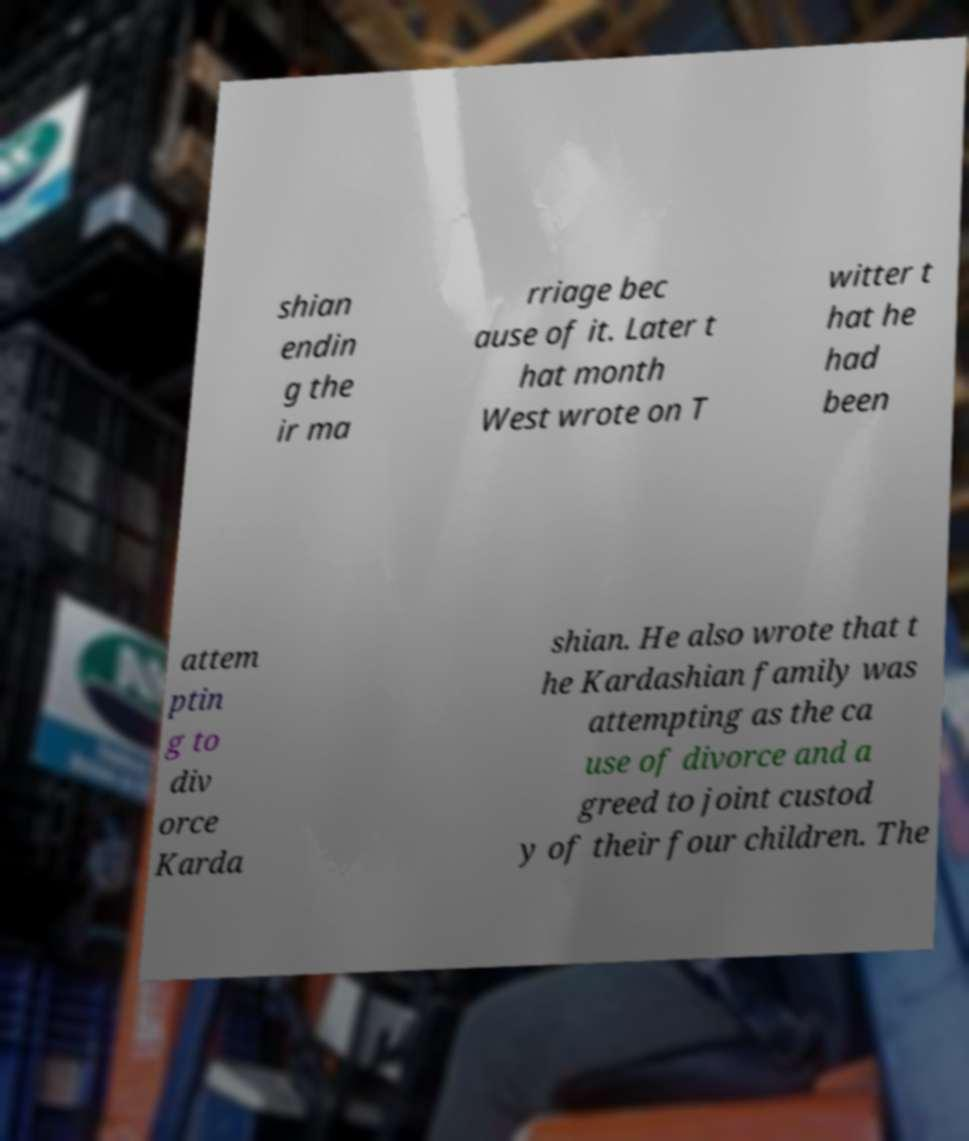Can you read and provide the text displayed in the image?This photo seems to have some interesting text. Can you extract and type it out for me? shian endin g the ir ma rriage bec ause of it. Later t hat month West wrote on T witter t hat he had been attem ptin g to div orce Karda shian. He also wrote that t he Kardashian family was attempting as the ca use of divorce and a greed to joint custod y of their four children. The 